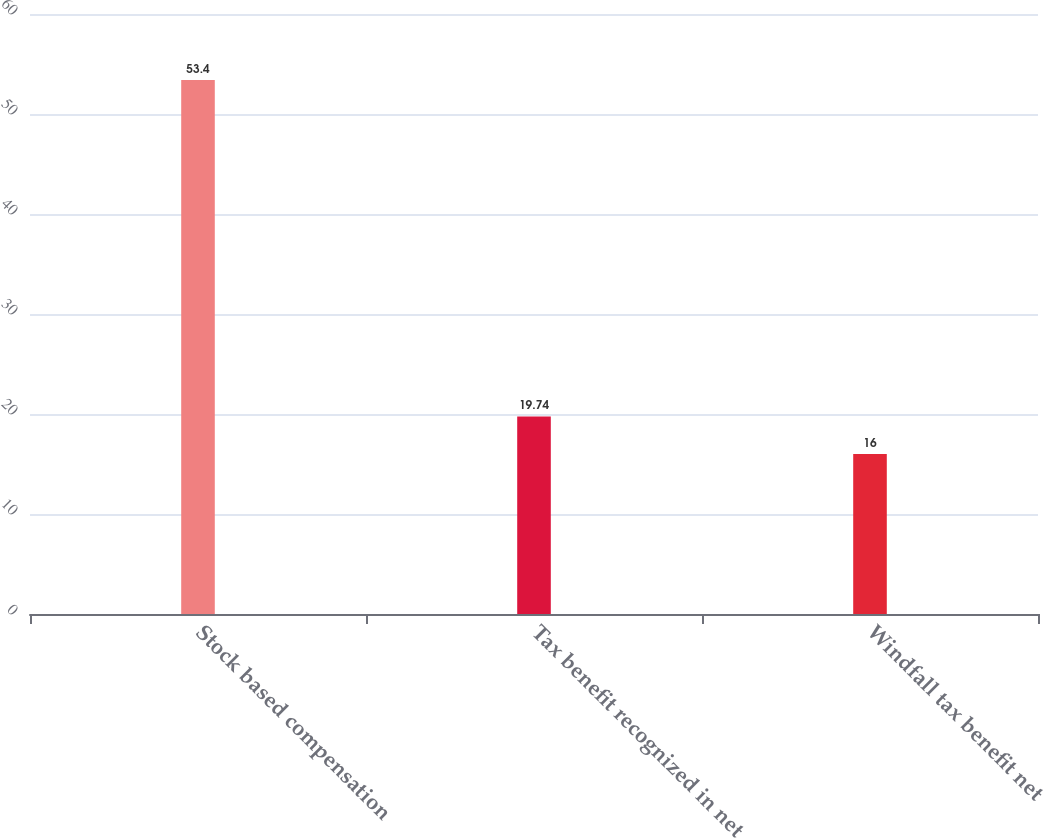Convert chart to OTSL. <chart><loc_0><loc_0><loc_500><loc_500><bar_chart><fcel>Stock based compensation<fcel>Tax benefit recognized in net<fcel>Windfall tax benefit net<nl><fcel>53.4<fcel>19.74<fcel>16<nl></chart> 